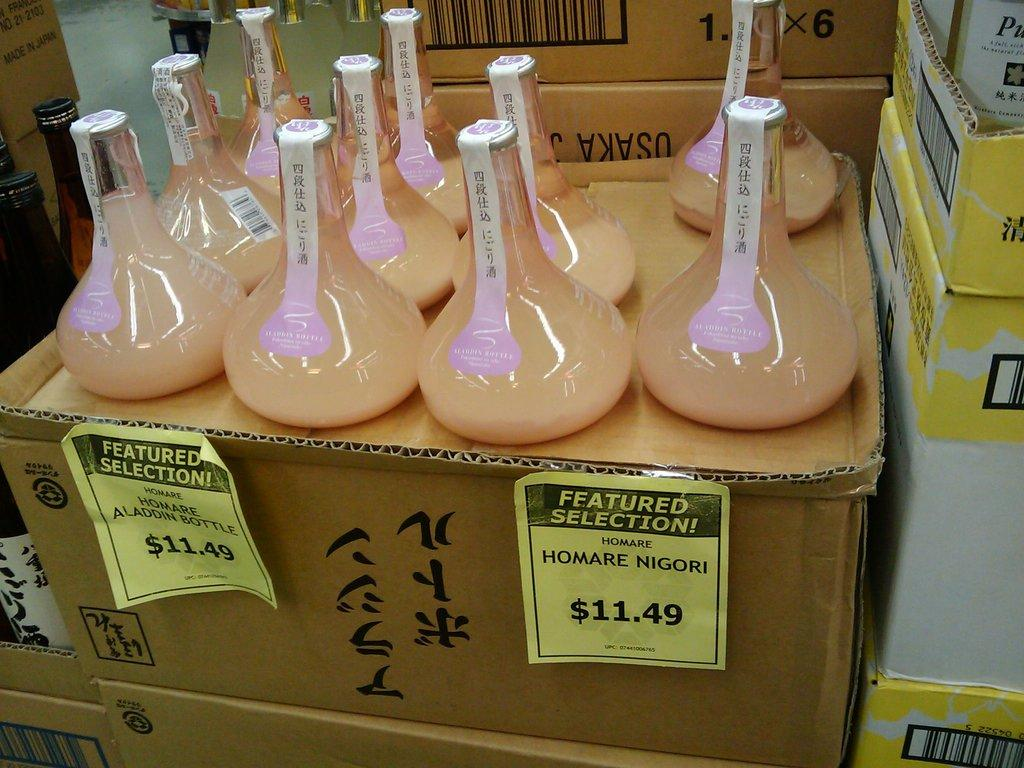Provide a one-sentence caption for the provided image. Bottles of Homare are displayed and they are $11.49 each. 